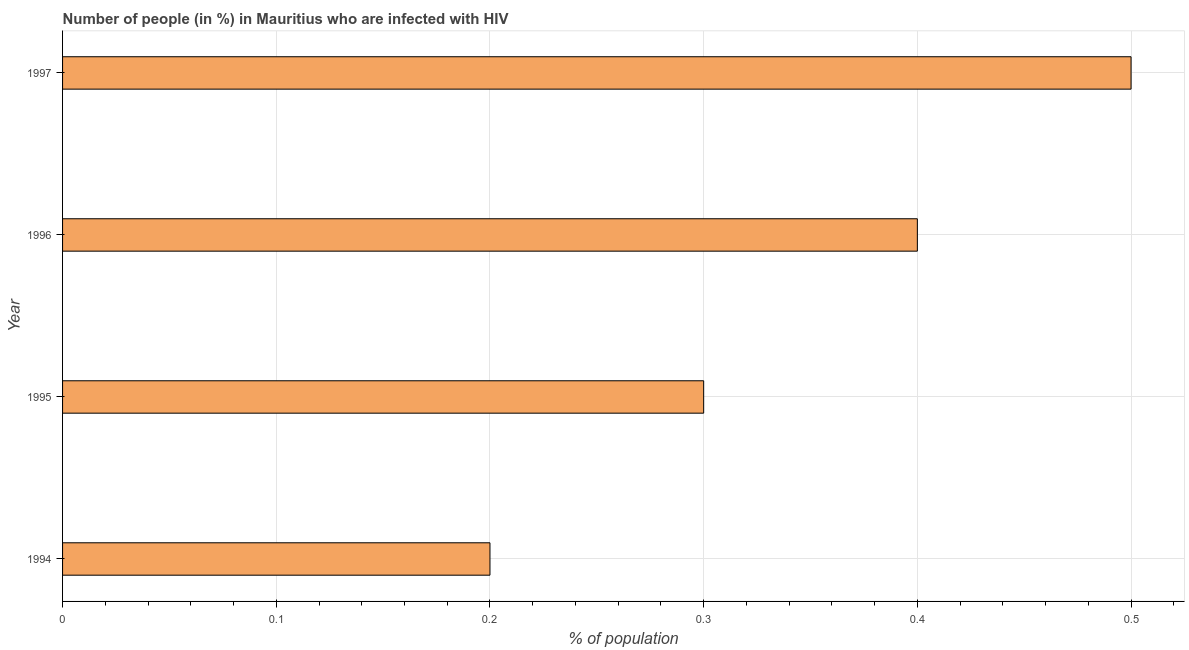Does the graph contain grids?
Offer a terse response. Yes. What is the title of the graph?
Give a very brief answer. Number of people (in %) in Mauritius who are infected with HIV. What is the label or title of the X-axis?
Offer a terse response. % of population. Across all years, what is the maximum number of people infected with hiv?
Offer a very short reply. 0.5. What is the average number of people infected with hiv per year?
Provide a short and direct response. 0.35. Do a majority of the years between 1995 and 1994 (inclusive) have number of people infected with hiv greater than 0.38 %?
Provide a succinct answer. No. Is the number of people infected with hiv in 1995 less than that in 1996?
Provide a short and direct response. Yes. What is the difference between the highest and the second highest number of people infected with hiv?
Give a very brief answer. 0.1. Is the sum of the number of people infected with hiv in 1995 and 1996 greater than the maximum number of people infected with hiv across all years?
Provide a succinct answer. Yes. In how many years, is the number of people infected with hiv greater than the average number of people infected with hiv taken over all years?
Your answer should be very brief. 2. How many bars are there?
Offer a terse response. 4. What is the % of population of 1995?
Your answer should be very brief. 0.3. What is the % of population in 1996?
Offer a terse response. 0.4. What is the difference between the % of population in 1994 and 1996?
Your answer should be compact. -0.2. What is the difference between the % of population in 1994 and 1997?
Provide a succinct answer. -0.3. What is the difference between the % of population in 1995 and 1996?
Your answer should be compact. -0.1. What is the ratio of the % of population in 1994 to that in 1995?
Make the answer very short. 0.67. What is the ratio of the % of population in 1994 to that in 1996?
Ensure brevity in your answer.  0.5. What is the ratio of the % of population in 1995 to that in 1997?
Keep it short and to the point. 0.6. 